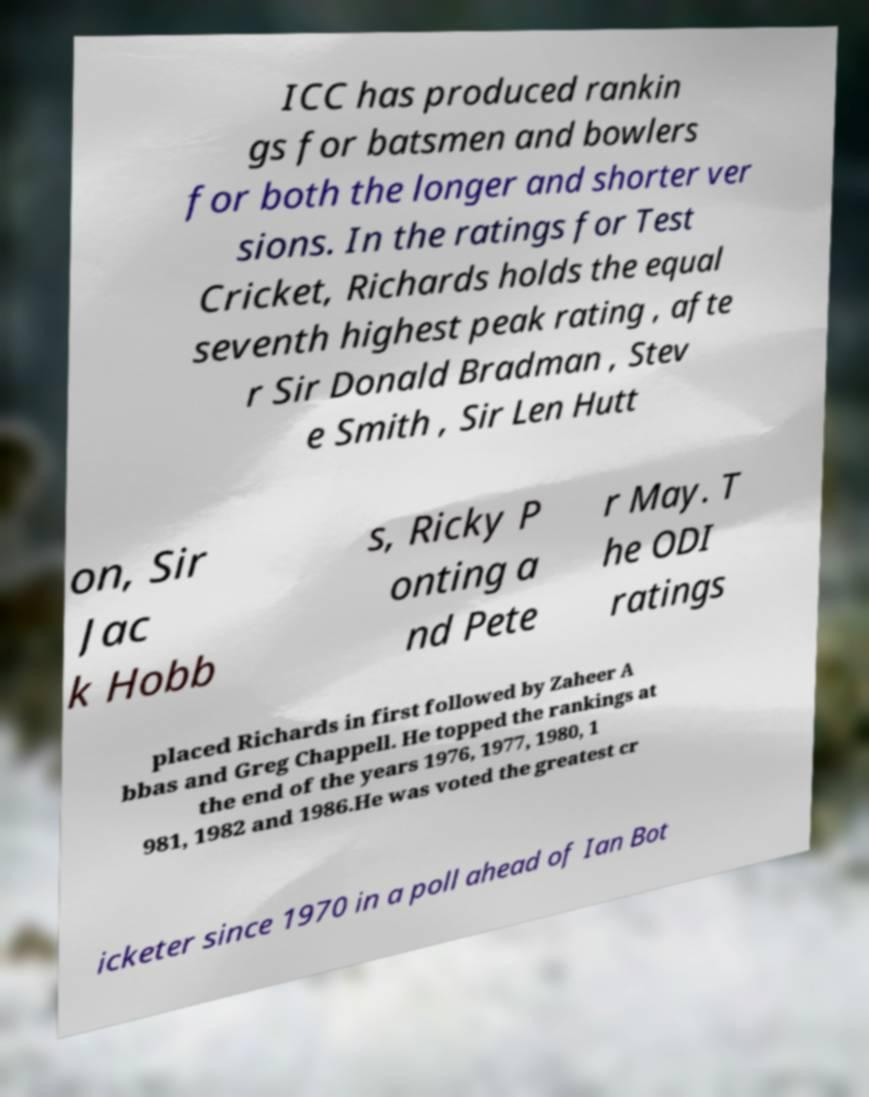Please read and relay the text visible in this image. What does it say? ICC has produced rankin gs for batsmen and bowlers for both the longer and shorter ver sions. In the ratings for Test Cricket, Richards holds the equal seventh highest peak rating , afte r Sir Donald Bradman , Stev e Smith , Sir Len Hutt on, Sir Jac k Hobb s, Ricky P onting a nd Pete r May. T he ODI ratings placed Richards in first followed by Zaheer A bbas and Greg Chappell. He topped the rankings at the end of the years 1976, 1977, 1980, 1 981, 1982 and 1986.He was voted the greatest cr icketer since 1970 in a poll ahead of Ian Bot 